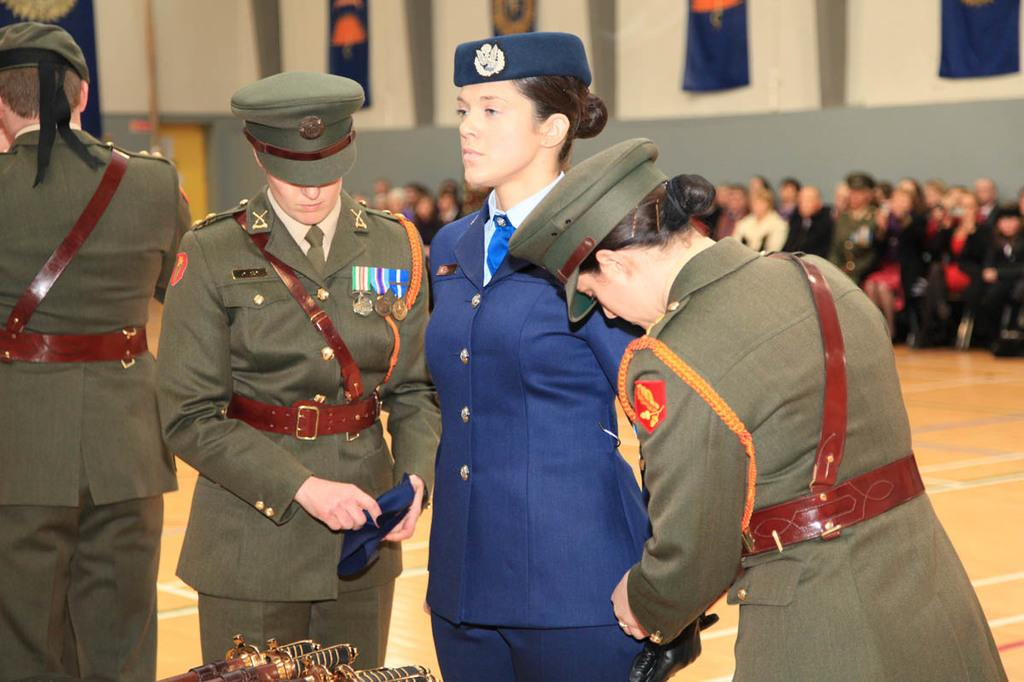What can be observed about the people in the image? There are standing in the image and are wearing uniforms. What is happening in the background of the image? There is a crowd sitting in the background of the image. What is on the wall in the image? Boards are placed on the wall. What is the nature of the wall in the image? There is a wall visible in the image. What type of crush can be seen in the image? There is no crush present in the image. 